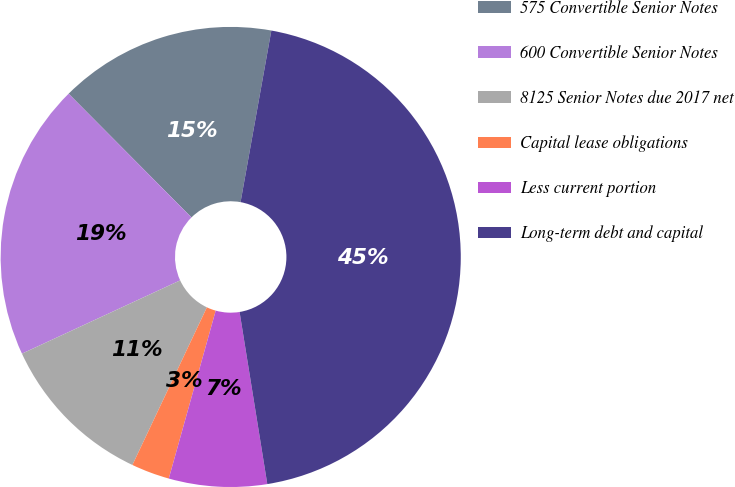Convert chart to OTSL. <chart><loc_0><loc_0><loc_500><loc_500><pie_chart><fcel>575 Convertible Senior Notes<fcel>600 Convertible Senior Notes<fcel>8125 Senior Notes due 2017 net<fcel>Capital lease obligations<fcel>Less current portion<fcel>Long-term debt and capital<nl><fcel>15.27%<fcel>19.46%<fcel>11.07%<fcel>2.69%<fcel>6.88%<fcel>44.63%<nl></chart> 